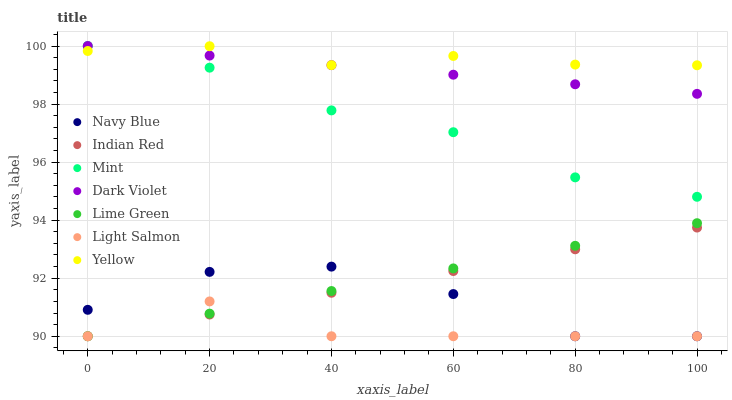Does Light Salmon have the minimum area under the curve?
Answer yes or no. Yes. Does Yellow have the maximum area under the curve?
Answer yes or no. Yes. Does Navy Blue have the minimum area under the curve?
Answer yes or no. No. Does Navy Blue have the maximum area under the curve?
Answer yes or no. No. Is Indian Red the smoothest?
Answer yes or no. Yes. Is Navy Blue the roughest?
Answer yes or no. Yes. Is Dark Violet the smoothest?
Answer yes or no. No. Is Dark Violet the roughest?
Answer yes or no. No. Does Light Salmon have the lowest value?
Answer yes or no. Yes. Does Dark Violet have the lowest value?
Answer yes or no. No. Does Mint have the highest value?
Answer yes or no. Yes. Does Navy Blue have the highest value?
Answer yes or no. No. Is Navy Blue less than Yellow?
Answer yes or no. Yes. Is Mint greater than Navy Blue?
Answer yes or no. Yes. Does Indian Red intersect Navy Blue?
Answer yes or no. Yes. Is Indian Red less than Navy Blue?
Answer yes or no. No. Is Indian Red greater than Navy Blue?
Answer yes or no. No. Does Navy Blue intersect Yellow?
Answer yes or no. No. 